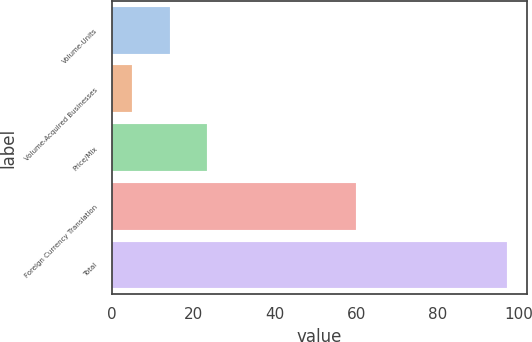Convert chart. <chart><loc_0><loc_0><loc_500><loc_500><bar_chart><fcel>Volume-Units<fcel>Volume-Acquired Businesses<fcel>Price/Mix<fcel>Foreign Currency Translation<fcel>Total<nl><fcel>14.2<fcel>5<fcel>23.4<fcel>59.9<fcel>97<nl></chart> 